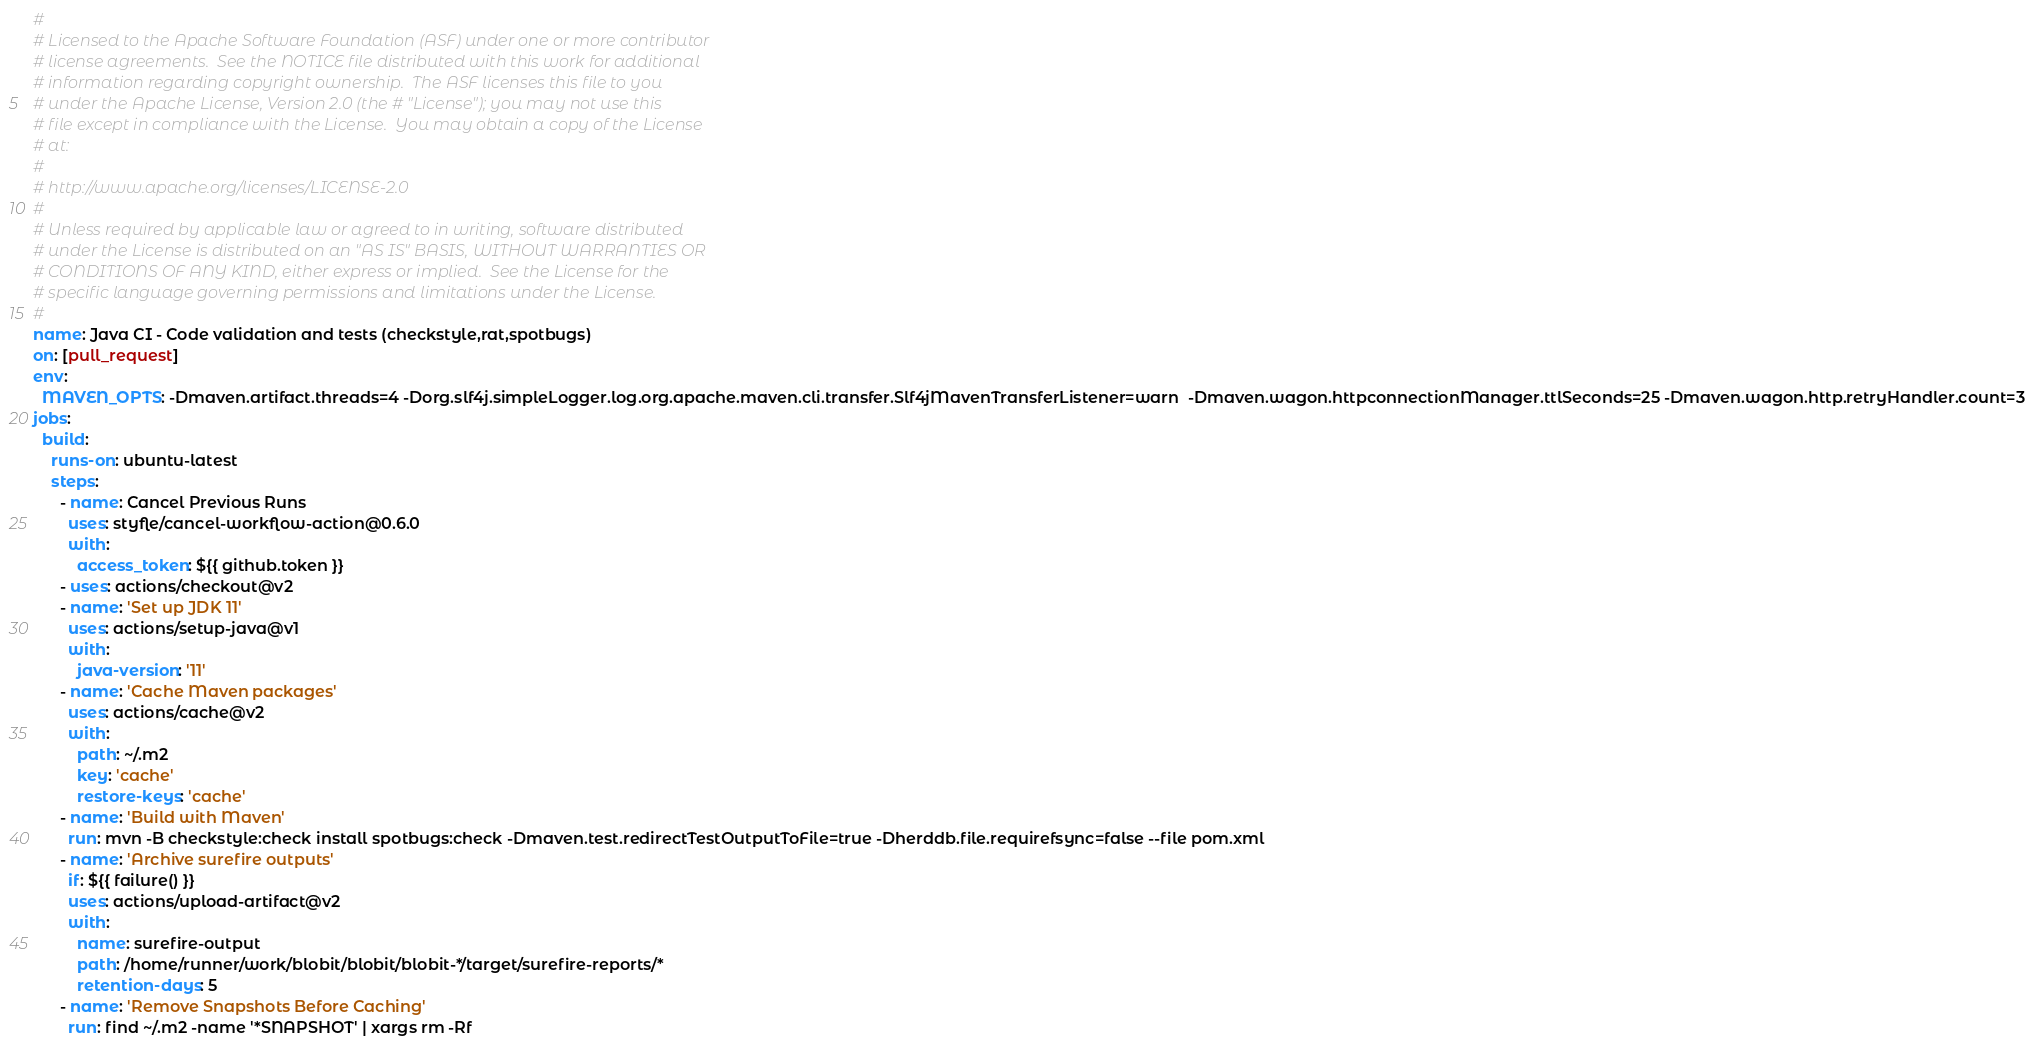<code> <loc_0><loc_0><loc_500><loc_500><_YAML_>#
# Licensed to the Apache Software Foundation (ASF) under one or more contributor
# license agreements.  See the NOTICE file distributed with this work for additional
# information regarding copyright ownership.  The ASF licenses this file to you
# under the Apache License, Version 2.0 (the # "License"); you may not use this
# file except in compliance with the License.  You may obtain a copy of the License
# at:
#
# http://www.apache.org/licenses/LICENSE-2.0
#
# Unless required by applicable law or agreed to in writing, software distributed
# under the License is distributed on an "AS IS" BASIS, WITHOUT WARRANTIES OR
# CONDITIONS OF ANY KIND, either express or implied.  See the License for the
# specific language governing permissions and limitations under the License.
#
name: Java CI - Code validation and tests (checkstyle,rat,spotbugs)
on: [pull_request]
env:
  MAVEN_OPTS: -Dmaven.artifact.threads=4 -Dorg.slf4j.simpleLogger.log.org.apache.maven.cli.transfer.Slf4jMavenTransferListener=warn  -Dmaven.wagon.httpconnectionManager.ttlSeconds=25 -Dmaven.wagon.http.retryHandler.count=3
jobs:
  build:
    runs-on: ubuntu-latest
    steps:
      - name: Cancel Previous Runs
        uses: styfle/cancel-workflow-action@0.6.0
        with:
          access_token: ${{ github.token }}
      - uses: actions/checkout@v2
      - name: 'Set up JDK 11'
        uses: actions/setup-java@v1
        with:
          java-version: '11'
      - name: 'Cache Maven packages'
        uses: actions/cache@v2
        with:
          path: ~/.m2
          key: 'cache'
          restore-keys: 'cache'
      - name: 'Build with Maven'
        run: mvn -B checkstyle:check install spotbugs:check -Dmaven.test.redirectTestOutputToFile=true -Dherddb.file.requirefsync=false --file pom.xml
      - name: 'Archive surefire outputs'
        if: ${{ failure() }}
        uses: actions/upload-artifact@v2
        with:
          name: surefire-output
          path: /home/runner/work/blobit/blobit/blobit-*/target/surefire-reports/*
          retention-days: 5
      - name: 'Remove Snapshots Before Caching'
        run: find ~/.m2 -name '*SNAPSHOT' | xargs rm -Rf
</code> 